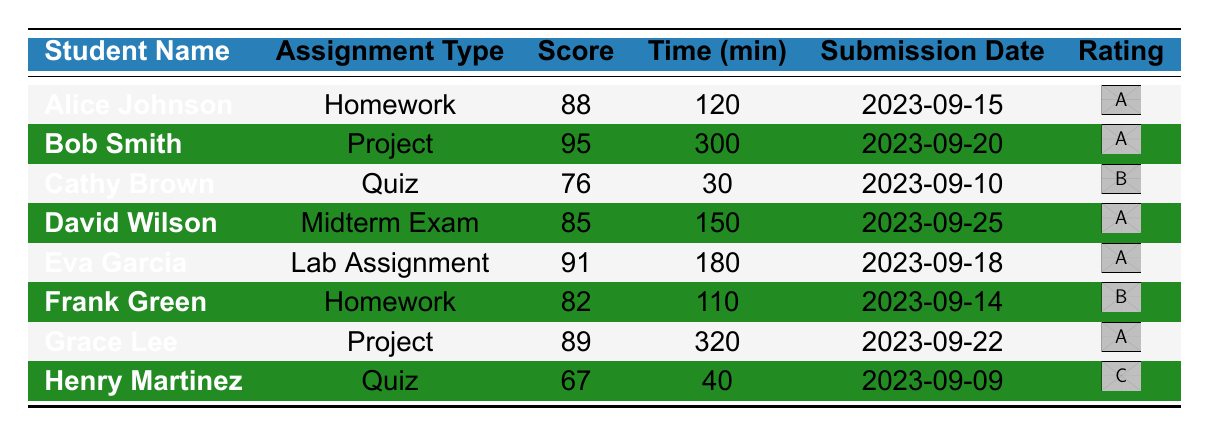What is the highest score achieved in the table? Looking through the scores, the highest score listed is 95, accomplished by Bob Smith for the Project assignment.
Answer: 95 What assignment type did Eva Garcia complete? By checking the assignment type column for Eva Garcia, we see she completed the Lab Assignment.
Answer: Lab Assignment How many minutes did Grace Lee spend on her Project? The completion time in minutes for Grace Lee is clearly listed as 320 minutes in the table.
Answer: 320 What is the average score of the students who submitted a Quiz? The scores for the Quiz assignments are 76 (Cathy Brown) and 67 (Henry Martinez). The average is calculated as (76 + 67) / 2 = 71.5.
Answer: 71.5 Did any student score below 70 in their assignments? Checking the scores, Henry Martinez scored 67, which is below 70, confirming that at least one student did indeed score below this mark.
Answer: Yes What is the total time spent by students on Homework assignments? Alice Johnson spent 120 minutes on Homework, and Frank Green spent 110 minutes. The total time is 120 + 110 = 230 minutes.
Answer: 230 Who had the longest completion time and what was the assignment type? Reviewing the completion times, Grace Lee's Project took the longest at 320 minutes.
Answer: Grace Lee, Project What percentage of students scored above 85? The scores above 85 are 88 (Alice Johnson), 91 (Eva Garcia), and 95 (Bob Smith), out of 8 total students, so the percentage is (3/8) * 100 = 37.5%.
Answer: 37.5% What was the average completion time for Midterm Exam and Lab Assignments combined? The completion time is 150 minutes for David Wilson (Midterm Exam) and 180 minutes for Eva Garcia (Lab Assignment). The average is calculated as (150 + 180) / 2 = 165 minutes.
Answer: 165 